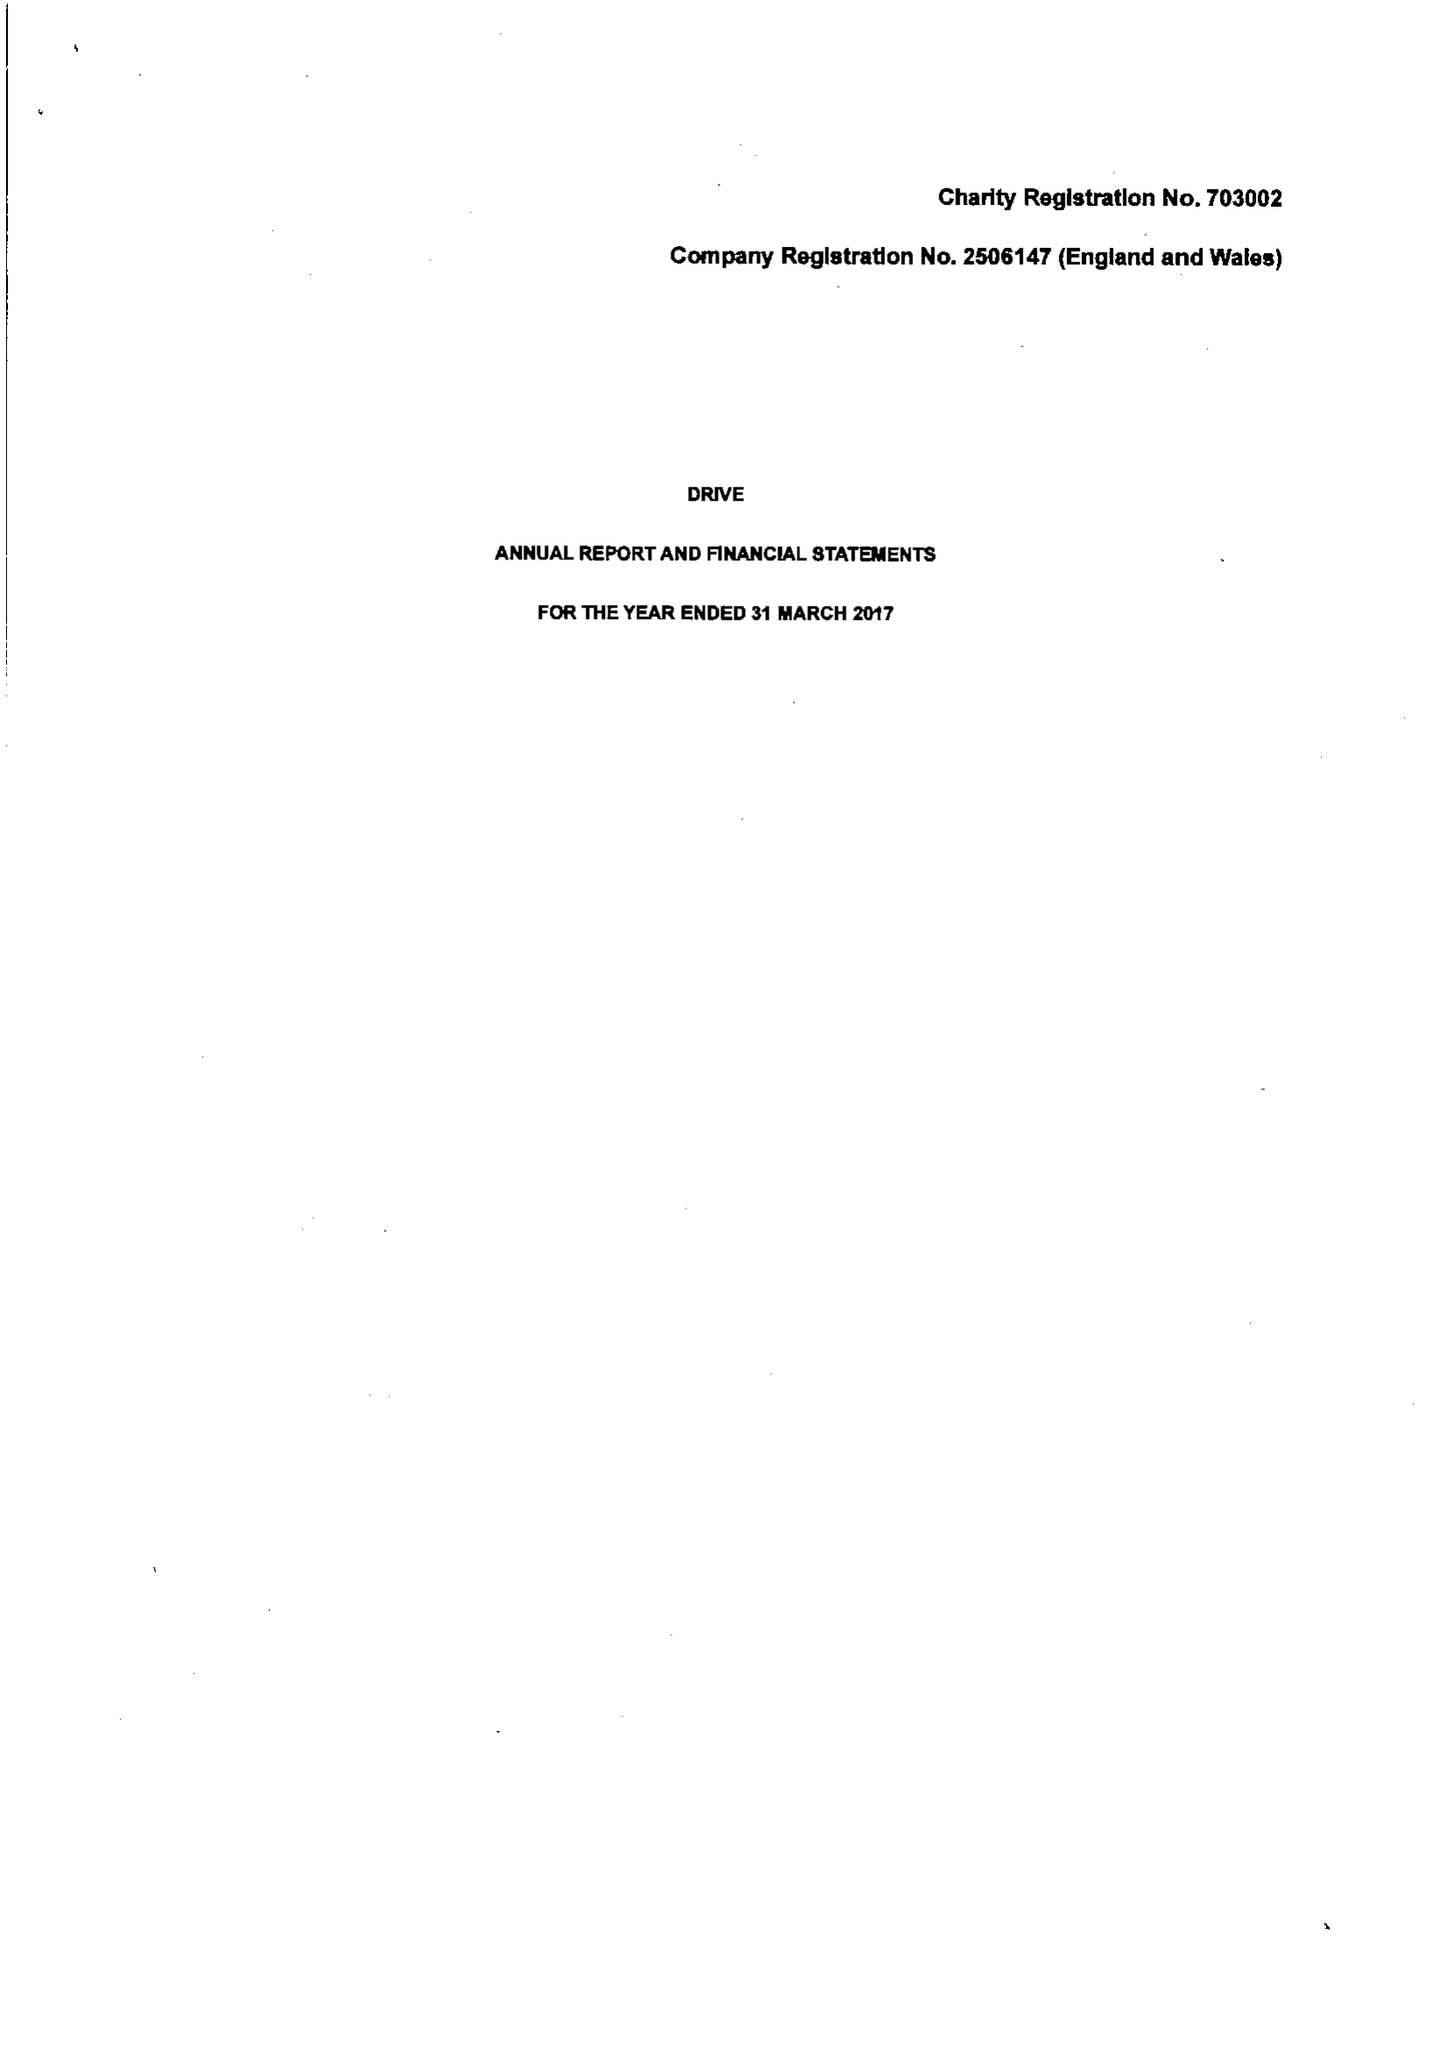What is the value for the charity_name?
Answer the question using a single word or phrase. Drive 